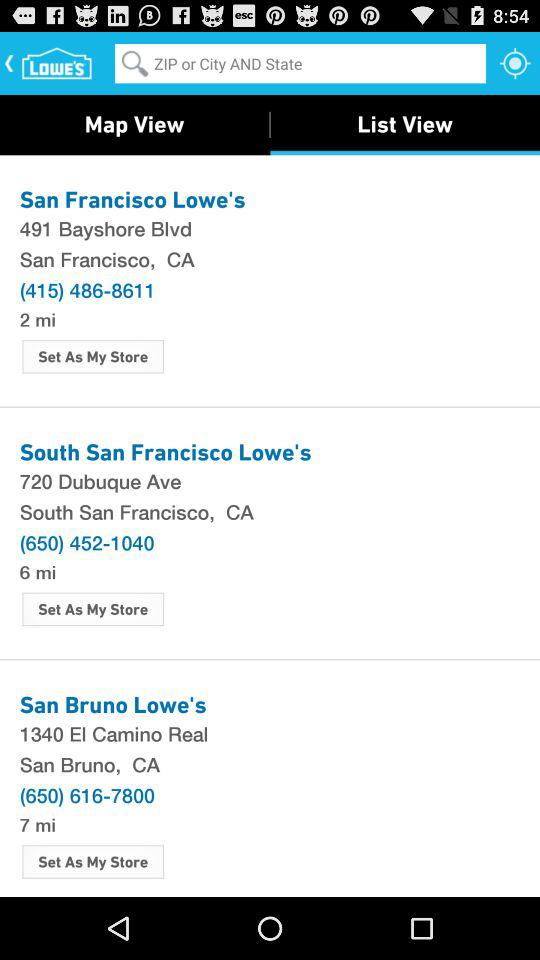Where is the San Francisco Lowe's located? The San Francisco Lowe's is located at 491 Bayshore Blvd., San Francisco, CA. 